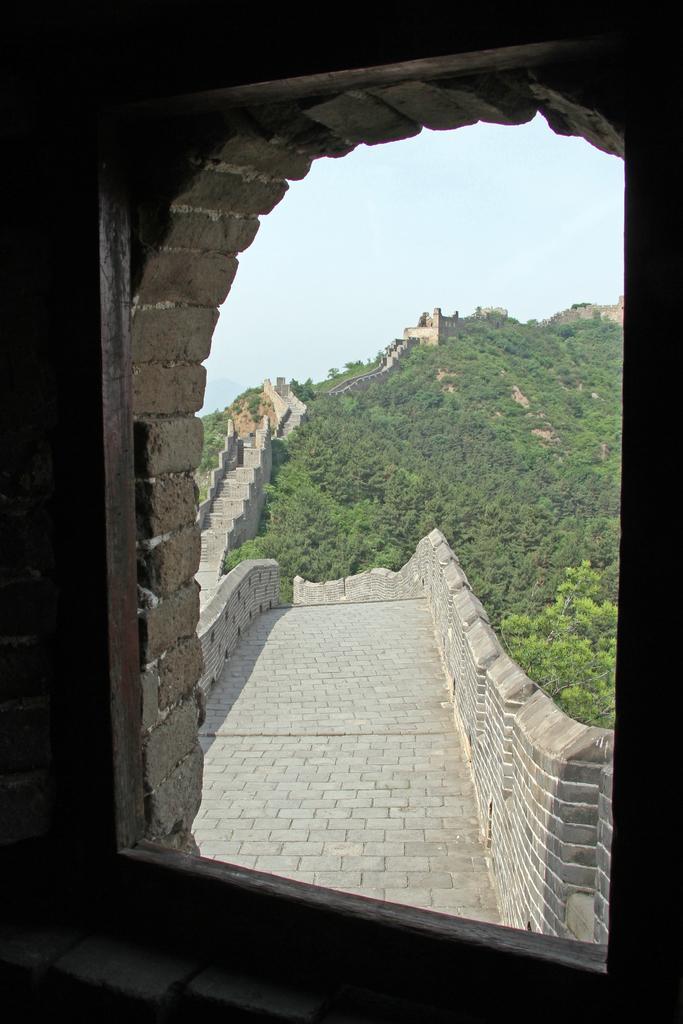In one or two sentences, can you explain what this image depicts? In this image from the brick window we can see the great wall of china, besides the wall there are trees. 